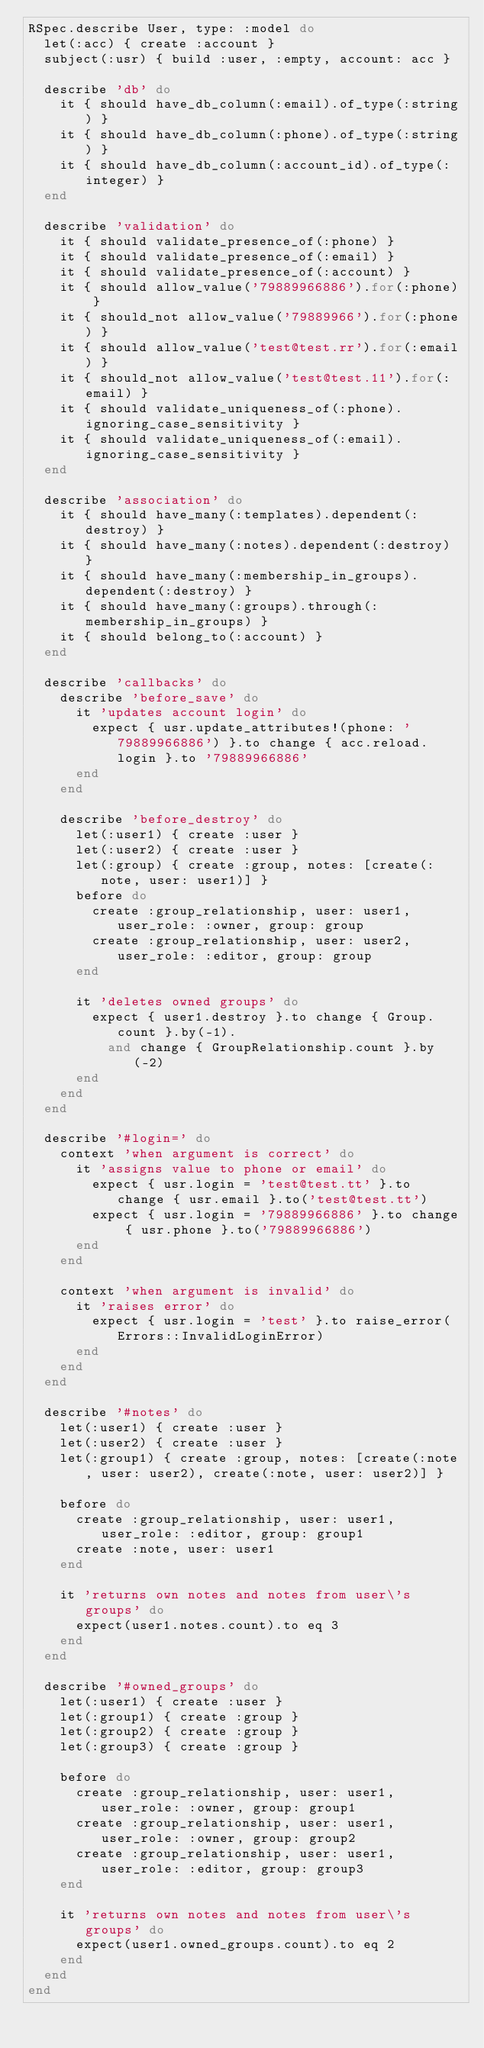Convert code to text. <code><loc_0><loc_0><loc_500><loc_500><_Ruby_>RSpec.describe User, type: :model do
  let(:acc) { create :account }
  subject(:usr) { build :user, :empty, account: acc }

  describe 'db' do
    it { should have_db_column(:email).of_type(:string) }
    it { should have_db_column(:phone).of_type(:string) }
    it { should have_db_column(:account_id).of_type(:integer) }
  end

  describe 'validation' do
    it { should validate_presence_of(:phone) }
    it { should validate_presence_of(:email) }
    it { should validate_presence_of(:account) }
    it { should allow_value('79889966886').for(:phone) }
    it { should_not allow_value('79889966').for(:phone) }
    it { should allow_value('test@test.rr').for(:email) }
    it { should_not allow_value('test@test.11').for(:email) }
    it { should validate_uniqueness_of(:phone).ignoring_case_sensitivity }
    it { should validate_uniqueness_of(:email).ignoring_case_sensitivity }
  end

  describe 'association' do
    it { should have_many(:templates).dependent(:destroy) }
    it { should have_many(:notes).dependent(:destroy) }
    it { should have_many(:membership_in_groups).dependent(:destroy) }
    it { should have_many(:groups).through(:membership_in_groups) }
    it { should belong_to(:account) }
  end

  describe 'callbacks' do
    describe 'before_save' do
      it 'updates account login' do
        expect { usr.update_attributes!(phone: '79889966886') }.to change { acc.reload.login }.to '79889966886'
      end
    end

    describe 'before_destroy' do
      let(:user1) { create :user }
      let(:user2) { create :user }
      let(:group) { create :group, notes: [create(:note, user: user1)] }
      before do
        create :group_relationship, user: user1, user_role: :owner, group: group
        create :group_relationship, user: user2, user_role: :editor, group: group
      end

      it 'deletes owned groups' do
        expect { user1.destroy }.to change { Group.count }.by(-1).
          and change { GroupRelationship.count }.by(-2)
      end
    end
  end

  describe '#login=' do
    context 'when argument is correct' do
      it 'assigns value to phone or email' do
        expect { usr.login = 'test@test.tt' }.to change { usr.email }.to('test@test.tt')
        expect { usr.login = '79889966886' }.to change { usr.phone }.to('79889966886')
      end
    end

    context 'when argument is invalid' do
      it 'raises error' do
        expect { usr.login = 'test' }.to raise_error(Errors::InvalidLoginError)
      end
    end
  end

  describe '#notes' do
    let(:user1) { create :user }
    let(:user2) { create :user }
    let(:group1) { create :group, notes: [create(:note, user: user2), create(:note, user: user2)] }

    before do
      create :group_relationship, user: user1, user_role: :editor, group: group1
      create :note, user: user1
    end

    it 'returns own notes and notes from user\'s groups' do
      expect(user1.notes.count).to eq 3
    end
  end

  describe '#owned_groups' do
    let(:user1) { create :user }
    let(:group1) { create :group }
    let(:group2) { create :group }
    let(:group3) { create :group }

    before do
      create :group_relationship, user: user1, user_role: :owner, group: group1
      create :group_relationship, user: user1, user_role: :owner, group: group2
      create :group_relationship, user: user1, user_role: :editor, group: group3
    end

    it 'returns own notes and notes from user\'s groups' do
      expect(user1.owned_groups.count).to eq 2
    end
  end
end
</code> 